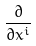<formula> <loc_0><loc_0><loc_500><loc_500>\frac { \partial } { \partial x ^ { i } }</formula> 